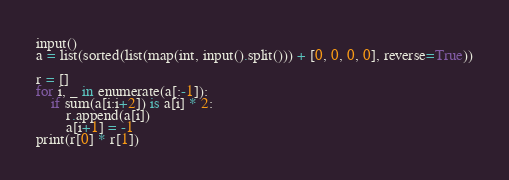Convert code to text. <code><loc_0><loc_0><loc_500><loc_500><_Python_>input()
a = list(sorted(list(map(int, input().split())) + [0, 0, 0, 0], reverse=True))

r = []
for i, _ in enumerate(a[:-1]):
    if sum(a[i:i+2]) is a[i] * 2:
        r.append(a[i])
        a[i+1] = -1
print(r[0] * r[1])
</code> 